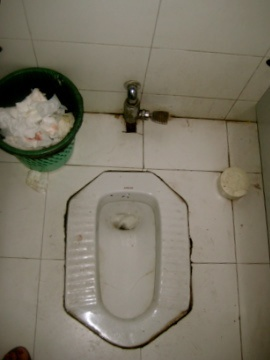Describe the objects in this image and their specific colors. I can see a toilet in black and gray tones in this image. 